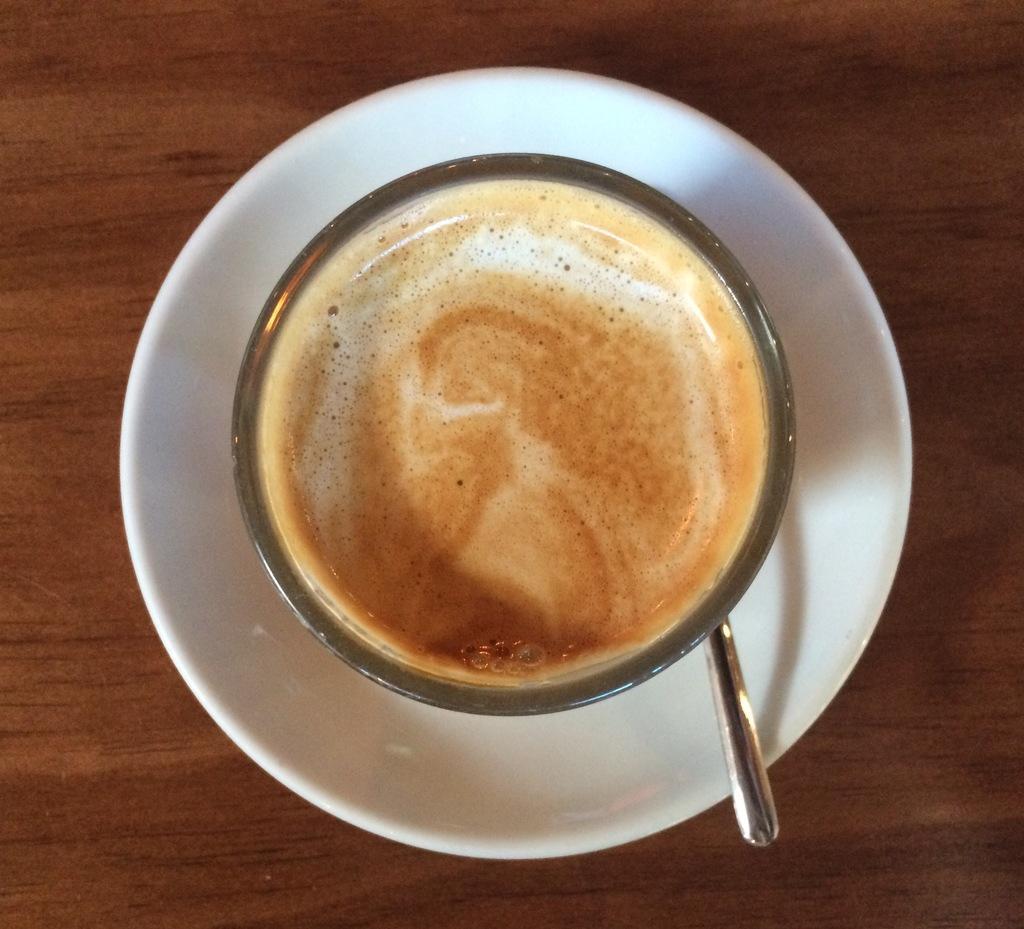Please provide a concise description of this image. In this image we can see a coffee cup, saucer and a spoon on the wooden object, which looks like a table. 